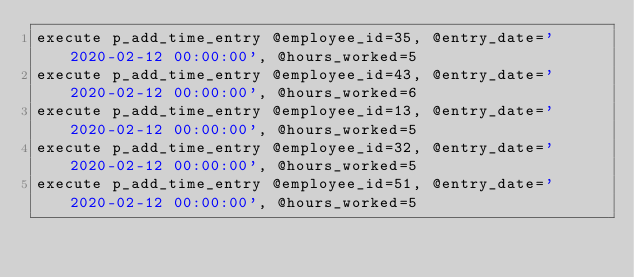Convert code to text. <code><loc_0><loc_0><loc_500><loc_500><_SQL_>execute p_add_time_entry @employee_id=35, @entry_date='2020-02-12 00:00:00', @hours_worked=5
execute p_add_time_entry @employee_id=43, @entry_date='2020-02-12 00:00:00', @hours_worked=6
execute p_add_time_entry @employee_id=13, @entry_date='2020-02-12 00:00:00', @hours_worked=5
execute p_add_time_entry @employee_id=32, @entry_date='2020-02-12 00:00:00', @hours_worked=5
execute p_add_time_entry @employee_id=51, @entry_date='2020-02-12 00:00:00', @hours_worked=5

</code> 